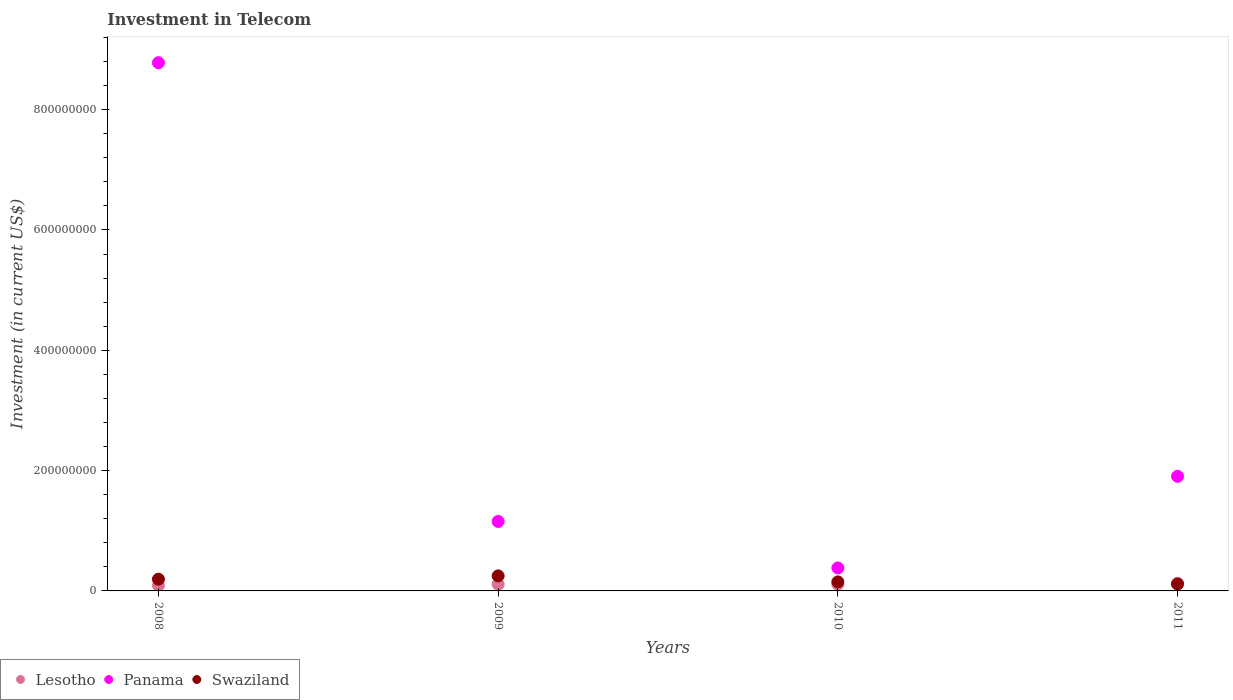Is the number of dotlines equal to the number of legend labels?
Offer a terse response. Yes. What is the amount invested in telecom in Lesotho in 2010?
Make the answer very short. 1.10e+07. Across all years, what is the maximum amount invested in telecom in Swaziland?
Keep it short and to the point. 2.50e+07. Across all years, what is the minimum amount invested in telecom in Panama?
Provide a succinct answer. 3.82e+07. What is the total amount invested in telecom in Lesotho in the graph?
Your response must be concise. 4.40e+07. What is the difference between the amount invested in telecom in Panama in 2009 and that in 2011?
Make the answer very short. -7.50e+07. What is the difference between the amount invested in telecom in Lesotho in 2009 and the amount invested in telecom in Swaziland in 2010?
Your answer should be very brief. -4.00e+06. What is the average amount invested in telecom in Lesotho per year?
Ensure brevity in your answer.  1.10e+07. In the year 2009, what is the difference between the amount invested in telecom in Swaziland and amount invested in telecom in Lesotho?
Offer a very short reply. 1.40e+07. What is the ratio of the amount invested in telecom in Lesotho in 2010 to that in 2011?
Keep it short and to the point. 0.87. Is the amount invested in telecom in Panama in 2008 less than that in 2009?
Your answer should be very brief. No. What is the difference between the highest and the second highest amount invested in telecom in Panama?
Provide a short and direct response. 6.88e+08. What is the difference between the highest and the lowest amount invested in telecom in Swaziland?
Offer a very short reply. 1.36e+07. In how many years, is the amount invested in telecom in Swaziland greater than the average amount invested in telecom in Swaziland taken over all years?
Keep it short and to the point. 2. Does the amount invested in telecom in Panama monotonically increase over the years?
Provide a succinct answer. No. How many dotlines are there?
Give a very brief answer. 3. How many years are there in the graph?
Make the answer very short. 4. Are the values on the major ticks of Y-axis written in scientific E-notation?
Offer a terse response. No. How many legend labels are there?
Provide a short and direct response. 3. What is the title of the graph?
Ensure brevity in your answer.  Investment in Telecom. Does "Belize" appear as one of the legend labels in the graph?
Your answer should be compact. No. What is the label or title of the Y-axis?
Provide a succinct answer. Investment (in current US$). What is the Investment (in current US$) of Lesotho in 2008?
Give a very brief answer. 9.30e+06. What is the Investment (in current US$) in Panama in 2008?
Offer a terse response. 8.78e+08. What is the Investment (in current US$) of Swaziland in 2008?
Offer a very short reply. 1.95e+07. What is the Investment (in current US$) of Lesotho in 2009?
Your response must be concise. 1.10e+07. What is the Investment (in current US$) of Panama in 2009?
Ensure brevity in your answer.  1.16e+08. What is the Investment (in current US$) of Swaziland in 2009?
Offer a very short reply. 2.50e+07. What is the Investment (in current US$) in Lesotho in 2010?
Your response must be concise. 1.10e+07. What is the Investment (in current US$) in Panama in 2010?
Ensure brevity in your answer.  3.82e+07. What is the Investment (in current US$) of Swaziland in 2010?
Provide a short and direct response. 1.50e+07. What is the Investment (in current US$) of Lesotho in 2011?
Keep it short and to the point. 1.27e+07. What is the Investment (in current US$) of Panama in 2011?
Keep it short and to the point. 1.90e+08. What is the Investment (in current US$) in Swaziland in 2011?
Offer a terse response. 1.14e+07. Across all years, what is the maximum Investment (in current US$) in Lesotho?
Your answer should be compact. 1.27e+07. Across all years, what is the maximum Investment (in current US$) of Panama?
Provide a succinct answer. 8.78e+08. Across all years, what is the maximum Investment (in current US$) in Swaziland?
Offer a terse response. 2.50e+07. Across all years, what is the minimum Investment (in current US$) in Lesotho?
Your answer should be compact. 9.30e+06. Across all years, what is the minimum Investment (in current US$) in Panama?
Your answer should be compact. 3.82e+07. Across all years, what is the minimum Investment (in current US$) of Swaziland?
Your answer should be very brief. 1.14e+07. What is the total Investment (in current US$) in Lesotho in the graph?
Offer a very short reply. 4.40e+07. What is the total Investment (in current US$) of Panama in the graph?
Your response must be concise. 1.22e+09. What is the total Investment (in current US$) of Swaziland in the graph?
Give a very brief answer. 7.09e+07. What is the difference between the Investment (in current US$) in Lesotho in 2008 and that in 2009?
Your answer should be compact. -1.70e+06. What is the difference between the Investment (in current US$) of Panama in 2008 and that in 2009?
Provide a short and direct response. 7.62e+08. What is the difference between the Investment (in current US$) of Swaziland in 2008 and that in 2009?
Make the answer very short. -5.50e+06. What is the difference between the Investment (in current US$) in Lesotho in 2008 and that in 2010?
Make the answer very short. -1.70e+06. What is the difference between the Investment (in current US$) in Panama in 2008 and that in 2010?
Offer a terse response. 8.40e+08. What is the difference between the Investment (in current US$) in Swaziland in 2008 and that in 2010?
Make the answer very short. 4.50e+06. What is the difference between the Investment (in current US$) of Lesotho in 2008 and that in 2011?
Provide a short and direct response. -3.40e+06. What is the difference between the Investment (in current US$) of Panama in 2008 and that in 2011?
Your response must be concise. 6.88e+08. What is the difference between the Investment (in current US$) of Swaziland in 2008 and that in 2011?
Your response must be concise. 8.10e+06. What is the difference between the Investment (in current US$) of Lesotho in 2009 and that in 2010?
Offer a terse response. 0. What is the difference between the Investment (in current US$) of Panama in 2009 and that in 2010?
Your answer should be compact. 7.73e+07. What is the difference between the Investment (in current US$) in Swaziland in 2009 and that in 2010?
Give a very brief answer. 1.00e+07. What is the difference between the Investment (in current US$) in Lesotho in 2009 and that in 2011?
Your answer should be compact. -1.70e+06. What is the difference between the Investment (in current US$) of Panama in 2009 and that in 2011?
Ensure brevity in your answer.  -7.50e+07. What is the difference between the Investment (in current US$) in Swaziland in 2009 and that in 2011?
Give a very brief answer. 1.36e+07. What is the difference between the Investment (in current US$) in Lesotho in 2010 and that in 2011?
Give a very brief answer. -1.70e+06. What is the difference between the Investment (in current US$) in Panama in 2010 and that in 2011?
Give a very brief answer. -1.52e+08. What is the difference between the Investment (in current US$) of Swaziland in 2010 and that in 2011?
Your answer should be very brief. 3.60e+06. What is the difference between the Investment (in current US$) in Lesotho in 2008 and the Investment (in current US$) in Panama in 2009?
Provide a succinct answer. -1.06e+08. What is the difference between the Investment (in current US$) in Lesotho in 2008 and the Investment (in current US$) in Swaziland in 2009?
Keep it short and to the point. -1.57e+07. What is the difference between the Investment (in current US$) of Panama in 2008 and the Investment (in current US$) of Swaziland in 2009?
Offer a terse response. 8.53e+08. What is the difference between the Investment (in current US$) of Lesotho in 2008 and the Investment (in current US$) of Panama in 2010?
Offer a terse response. -2.89e+07. What is the difference between the Investment (in current US$) in Lesotho in 2008 and the Investment (in current US$) in Swaziland in 2010?
Your response must be concise. -5.70e+06. What is the difference between the Investment (in current US$) in Panama in 2008 and the Investment (in current US$) in Swaziland in 2010?
Provide a short and direct response. 8.63e+08. What is the difference between the Investment (in current US$) in Lesotho in 2008 and the Investment (in current US$) in Panama in 2011?
Offer a terse response. -1.81e+08. What is the difference between the Investment (in current US$) in Lesotho in 2008 and the Investment (in current US$) in Swaziland in 2011?
Your answer should be compact. -2.10e+06. What is the difference between the Investment (in current US$) in Panama in 2008 and the Investment (in current US$) in Swaziland in 2011?
Offer a terse response. 8.67e+08. What is the difference between the Investment (in current US$) of Lesotho in 2009 and the Investment (in current US$) of Panama in 2010?
Keep it short and to the point. -2.72e+07. What is the difference between the Investment (in current US$) in Panama in 2009 and the Investment (in current US$) in Swaziland in 2010?
Your response must be concise. 1.00e+08. What is the difference between the Investment (in current US$) in Lesotho in 2009 and the Investment (in current US$) in Panama in 2011?
Provide a short and direct response. -1.80e+08. What is the difference between the Investment (in current US$) in Lesotho in 2009 and the Investment (in current US$) in Swaziland in 2011?
Offer a terse response. -4.00e+05. What is the difference between the Investment (in current US$) in Panama in 2009 and the Investment (in current US$) in Swaziland in 2011?
Your answer should be compact. 1.04e+08. What is the difference between the Investment (in current US$) in Lesotho in 2010 and the Investment (in current US$) in Panama in 2011?
Ensure brevity in your answer.  -1.80e+08. What is the difference between the Investment (in current US$) of Lesotho in 2010 and the Investment (in current US$) of Swaziland in 2011?
Make the answer very short. -4.00e+05. What is the difference between the Investment (in current US$) in Panama in 2010 and the Investment (in current US$) in Swaziland in 2011?
Give a very brief answer. 2.68e+07. What is the average Investment (in current US$) of Lesotho per year?
Provide a short and direct response. 1.10e+07. What is the average Investment (in current US$) in Panama per year?
Your answer should be very brief. 3.06e+08. What is the average Investment (in current US$) of Swaziland per year?
Make the answer very short. 1.77e+07. In the year 2008, what is the difference between the Investment (in current US$) of Lesotho and Investment (in current US$) of Panama?
Your answer should be very brief. -8.69e+08. In the year 2008, what is the difference between the Investment (in current US$) of Lesotho and Investment (in current US$) of Swaziland?
Your answer should be compact. -1.02e+07. In the year 2008, what is the difference between the Investment (in current US$) in Panama and Investment (in current US$) in Swaziland?
Keep it short and to the point. 8.58e+08. In the year 2009, what is the difference between the Investment (in current US$) in Lesotho and Investment (in current US$) in Panama?
Give a very brief answer. -1.04e+08. In the year 2009, what is the difference between the Investment (in current US$) of Lesotho and Investment (in current US$) of Swaziland?
Ensure brevity in your answer.  -1.40e+07. In the year 2009, what is the difference between the Investment (in current US$) of Panama and Investment (in current US$) of Swaziland?
Give a very brief answer. 9.05e+07. In the year 2010, what is the difference between the Investment (in current US$) in Lesotho and Investment (in current US$) in Panama?
Your response must be concise. -2.72e+07. In the year 2010, what is the difference between the Investment (in current US$) in Lesotho and Investment (in current US$) in Swaziland?
Provide a short and direct response. -4.00e+06. In the year 2010, what is the difference between the Investment (in current US$) in Panama and Investment (in current US$) in Swaziland?
Offer a terse response. 2.32e+07. In the year 2011, what is the difference between the Investment (in current US$) in Lesotho and Investment (in current US$) in Panama?
Your answer should be compact. -1.78e+08. In the year 2011, what is the difference between the Investment (in current US$) in Lesotho and Investment (in current US$) in Swaziland?
Provide a succinct answer. 1.30e+06. In the year 2011, what is the difference between the Investment (in current US$) in Panama and Investment (in current US$) in Swaziland?
Your answer should be very brief. 1.79e+08. What is the ratio of the Investment (in current US$) in Lesotho in 2008 to that in 2009?
Provide a short and direct response. 0.85. What is the ratio of the Investment (in current US$) in Panama in 2008 to that in 2009?
Offer a terse response. 7.6. What is the ratio of the Investment (in current US$) in Swaziland in 2008 to that in 2009?
Make the answer very short. 0.78. What is the ratio of the Investment (in current US$) in Lesotho in 2008 to that in 2010?
Your response must be concise. 0.85. What is the ratio of the Investment (in current US$) in Panama in 2008 to that in 2010?
Provide a short and direct response. 22.98. What is the ratio of the Investment (in current US$) in Swaziland in 2008 to that in 2010?
Ensure brevity in your answer.  1.3. What is the ratio of the Investment (in current US$) in Lesotho in 2008 to that in 2011?
Your response must be concise. 0.73. What is the ratio of the Investment (in current US$) of Panama in 2008 to that in 2011?
Offer a terse response. 4.61. What is the ratio of the Investment (in current US$) of Swaziland in 2008 to that in 2011?
Your response must be concise. 1.71. What is the ratio of the Investment (in current US$) of Panama in 2009 to that in 2010?
Offer a very short reply. 3.02. What is the ratio of the Investment (in current US$) of Lesotho in 2009 to that in 2011?
Your response must be concise. 0.87. What is the ratio of the Investment (in current US$) in Panama in 2009 to that in 2011?
Ensure brevity in your answer.  0.61. What is the ratio of the Investment (in current US$) of Swaziland in 2009 to that in 2011?
Offer a terse response. 2.19. What is the ratio of the Investment (in current US$) in Lesotho in 2010 to that in 2011?
Offer a very short reply. 0.87. What is the ratio of the Investment (in current US$) of Panama in 2010 to that in 2011?
Provide a short and direct response. 0.2. What is the ratio of the Investment (in current US$) of Swaziland in 2010 to that in 2011?
Keep it short and to the point. 1.32. What is the difference between the highest and the second highest Investment (in current US$) of Lesotho?
Provide a succinct answer. 1.70e+06. What is the difference between the highest and the second highest Investment (in current US$) in Panama?
Ensure brevity in your answer.  6.88e+08. What is the difference between the highest and the second highest Investment (in current US$) of Swaziland?
Provide a short and direct response. 5.50e+06. What is the difference between the highest and the lowest Investment (in current US$) in Lesotho?
Provide a short and direct response. 3.40e+06. What is the difference between the highest and the lowest Investment (in current US$) in Panama?
Keep it short and to the point. 8.40e+08. What is the difference between the highest and the lowest Investment (in current US$) in Swaziland?
Offer a terse response. 1.36e+07. 